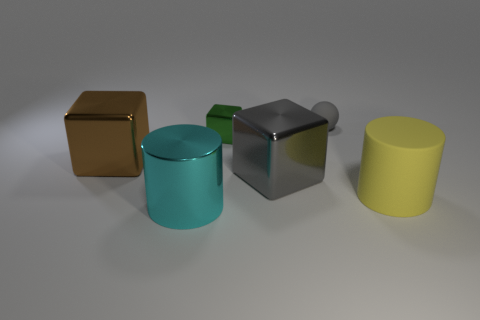There is a big block that is right of the green cube on the right side of the large cylinder on the left side of the gray matte sphere; what color is it?
Your answer should be very brief. Gray. The object that is made of the same material as the small ball is what color?
Give a very brief answer. Yellow. How many large cylinders have the same material as the small gray object?
Offer a terse response. 1. Do the gray thing that is behind the brown thing and the gray metallic thing have the same size?
Ensure brevity in your answer.  No. The other cylinder that is the same size as the yellow cylinder is what color?
Your answer should be very brief. Cyan. There is a large metallic cylinder; what number of big cylinders are to the right of it?
Ensure brevity in your answer.  1. Is there a tiny gray rubber sphere?
Your answer should be compact. Yes. There is a gray matte sphere that is right of the gray object in front of the shiny object that is to the left of the cyan shiny thing; how big is it?
Your answer should be compact. Small. How many other things are the same size as the rubber cylinder?
Keep it short and to the point. 3. What size is the gray thing behind the green block?
Offer a terse response. Small. 